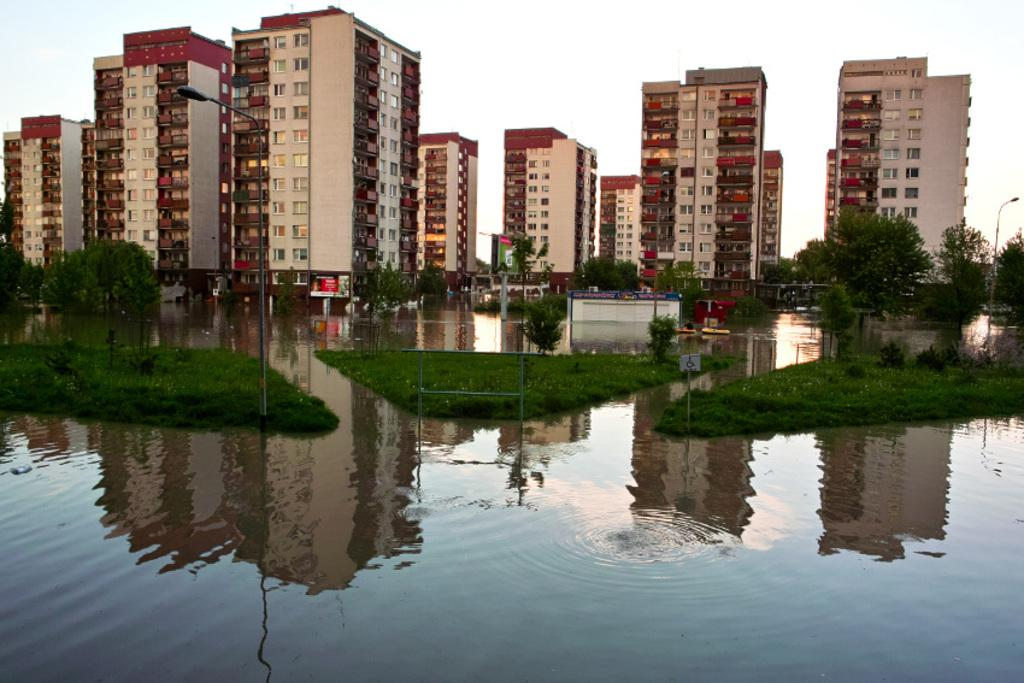What type of structures are present in the image? There is a group of buildings with windows in the image. What other objects can be seen in the image? Boards, a group of trees, grass, street poles, and water are visible in the image. What is the condition of the sky in the image? The sky is cloudy in the image. Can you see any fairies flying around the trees in the image? There are no fairies present in the image; it features a group of buildings, boards, trees, grass, street poles, water, and a cloudy sky. What type of vase is placed on the windowsill of the building in the image? There is no vase present on the windowsill of any building in the image. 